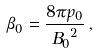<formula> <loc_0><loc_0><loc_500><loc_500>\beta _ { 0 } = \frac { 8 \pi p _ { 0 } } { { B _ { 0 } } ^ { 2 } } \, ,</formula> 